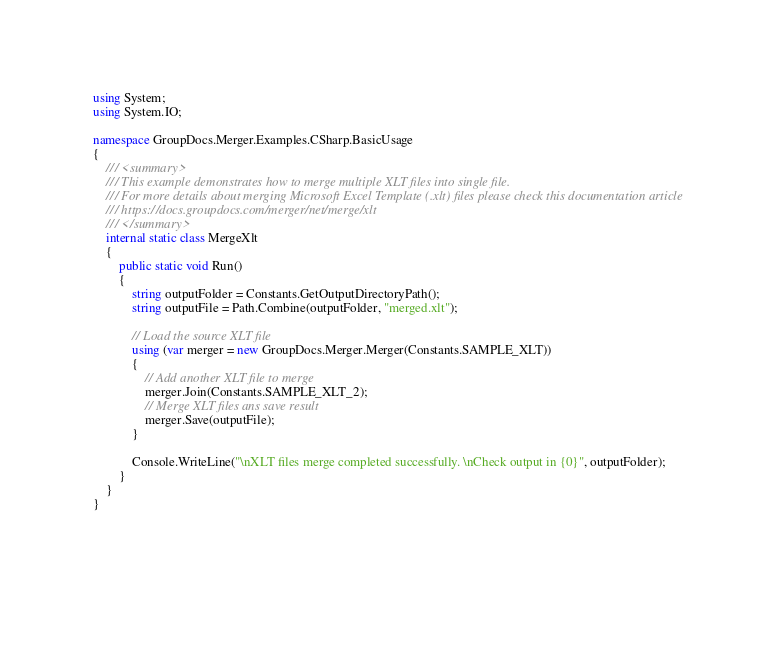<code> <loc_0><loc_0><loc_500><loc_500><_C#_>using System;
using System.IO;

namespace GroupDocs.Merger.Examples.CSharp.BasicUsage
{
    /// <summary>
    /// This example demonstrates how to merge multiple XLT files into single file.
    /// For more details about merging Microsoft Excel Template (.xlt) files please check this documentation article 
    /// https://docs.groupdocs.com/merger/net/merge/xlt
    /// </summary>
    internal static class MergeXlt
    {
        public static void Run()
        {            
            string outputFolder = Constants.GetOutputDirectoryPath();
            string outputFile = Path.Combine(outputFolder, "merged.xlt");
            
            // Load the source XLT file
            using (var merger = new GroupDocs.Merger.Merger(Constants.SAMPLE_XLT))
            {
                // Add another XLT file to merge
                merger.Join(Constants.SAMPLE_XLT_2);
                // Merge XLT files ans save result
                merger.Save(outputFile);
            }

            Console.WriteLine("\nXLT files merge completed successfully. \nCheck output in {0}", outputFolder);
        }
    }
}

            
            </code> 